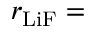Convert formula to latex. <formula><loc_0><loc_0><loc_500><loc_500>r _ { L i F } =</formula> 